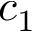<formula> <loc_0><loc_0><loc_500><loc_500>c _ { 1 }</formula> 